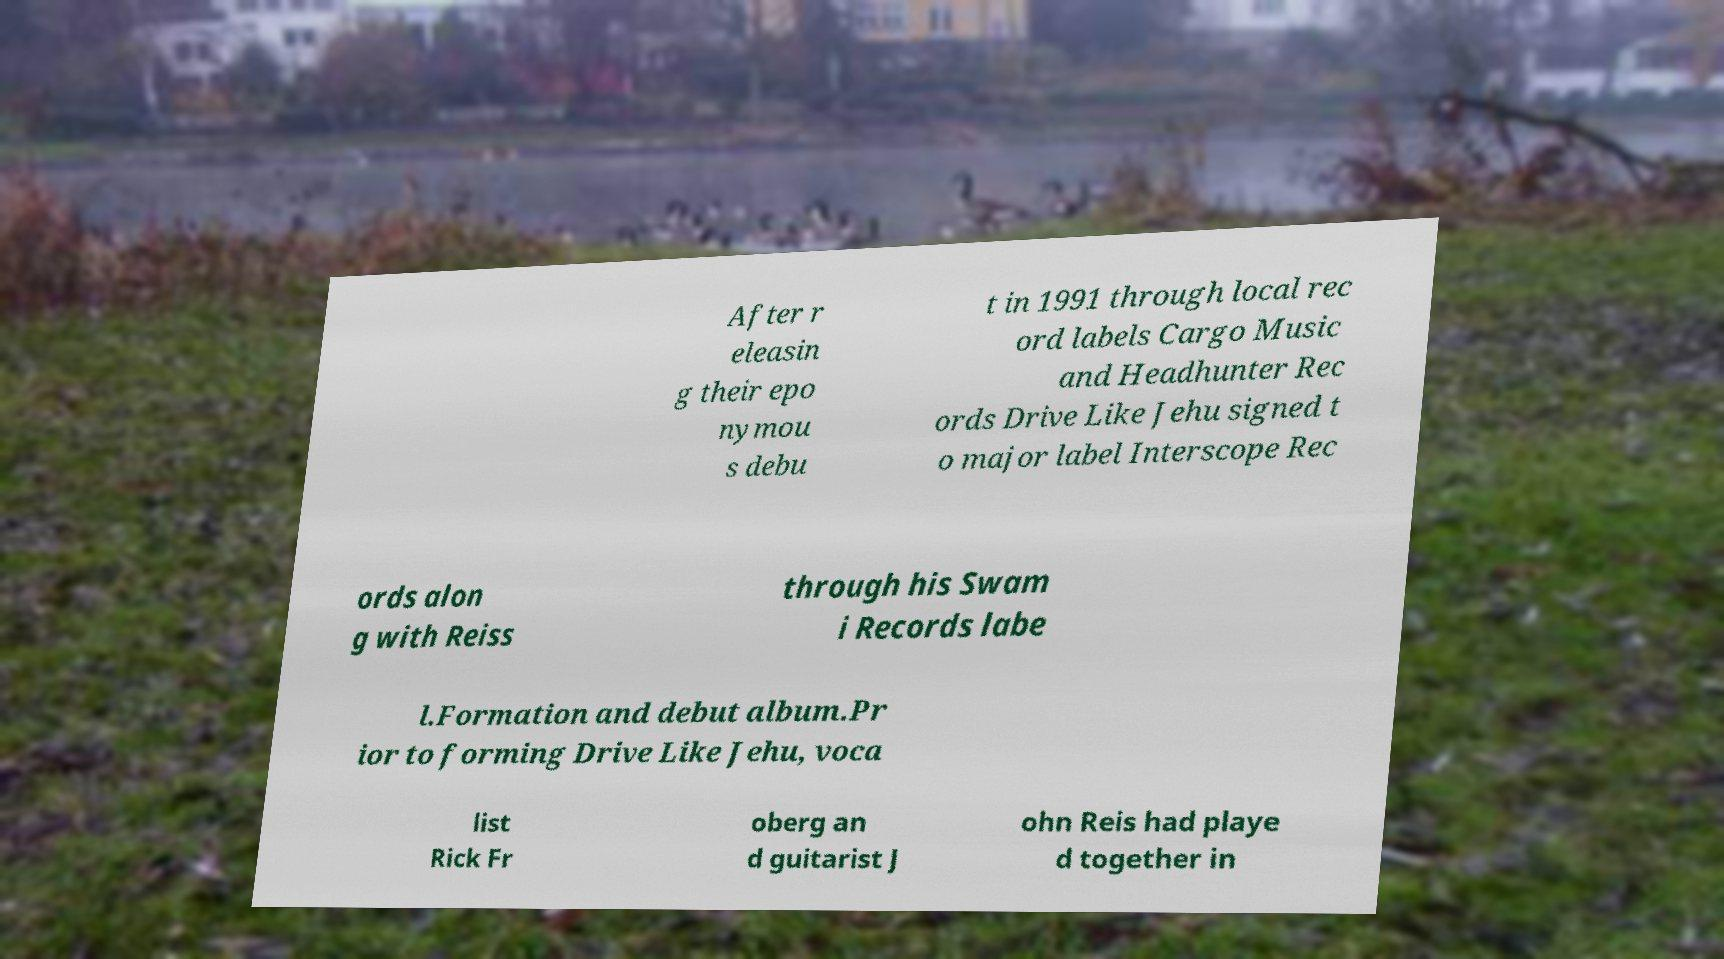Can you read and provide the text displayed in the image?This photo seems to have some interesting text. Can you extract and type it out for me? After r eleasin g their epo nymou s debu t in 1991 through local rec ord labels Cargo Music and Headhunter Rec ords Drive Like Jehu signed t o major label Interscope Rec ords alon g with Reiss through his Swam i Records labe l.Formation and debut album.Pr ior to forming Drive Like Jehu, voca list Rick Fr oberg an d guitarist J ohn Reis had playe d together in 